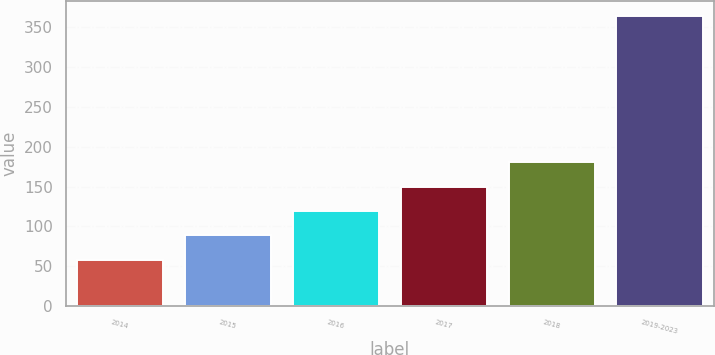Convert chart to OTSL. <chart><loc_0><loc_0><loc_500><loc_500><bar_chart><fcel>2014<fcel>2015<fcel>2016<fcel>2017<fcel>2018<fcel>2019-2023<nl><fcel>58<fcel>88.6<fcel>119.2<fcel>149.8<fcel>180.4<fcel>364<nl></chart> 